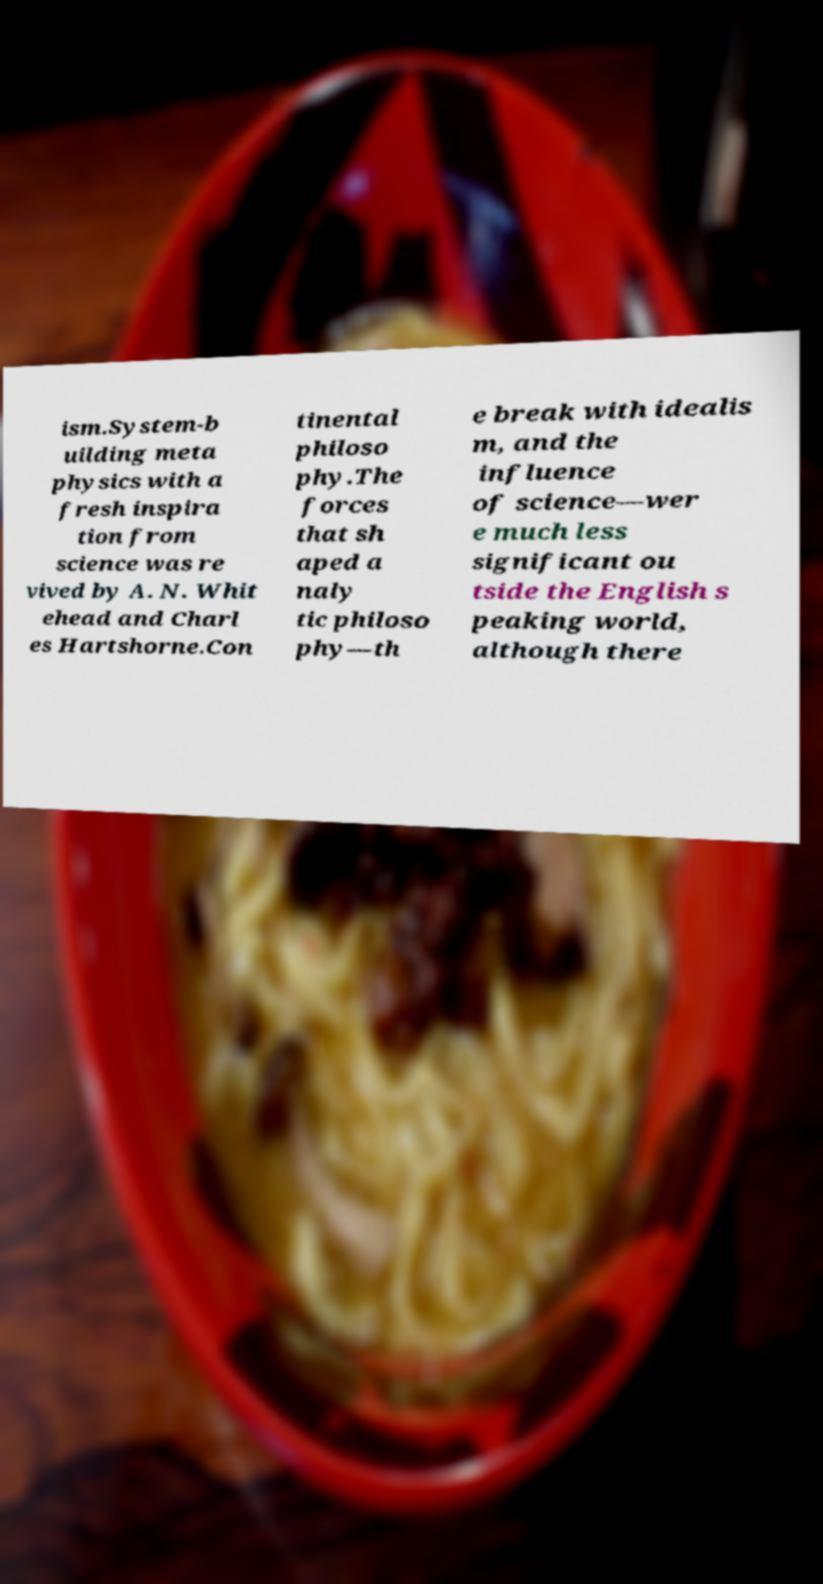For documentation purposes, I need the text within this image transcribed. Could you provide that? ism.System-b uilding meta physics with a fresh inspira tion from science was re vived by A. N. Whit ehead and Charl es Hartshorne.Con tinental philoso phy.The forces that sh aped a naly tic philoso phy—th e break with idealis m, and the influence of science—wer e much less significant ou tside the English s peaking world, although there 